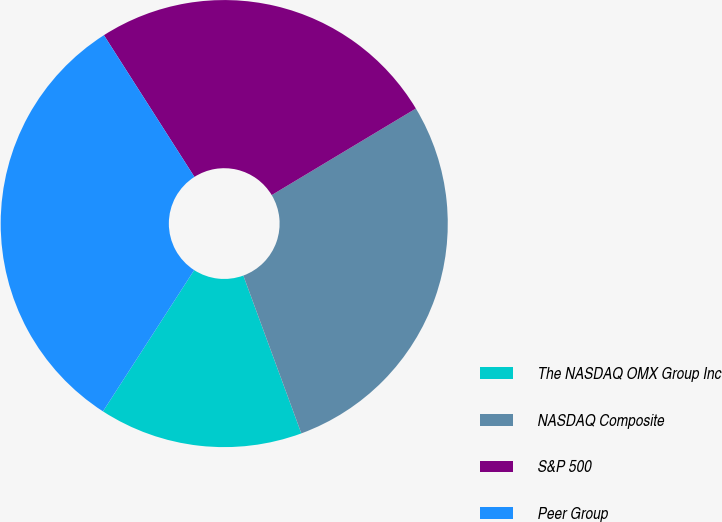Convert chart to OTSL. <chart><loc_0><loc_0><loc_500><loc_500><pie_chart><fcel>The NASDAQ OMX Group Inc<fcel>NASDAQ Composite<fcel>S&P 500<fcel>Peer Group<nl><fcel>14.73%<fcel>28.0%<fcel>25.44%<fcel>31.83%<nl></chart> 